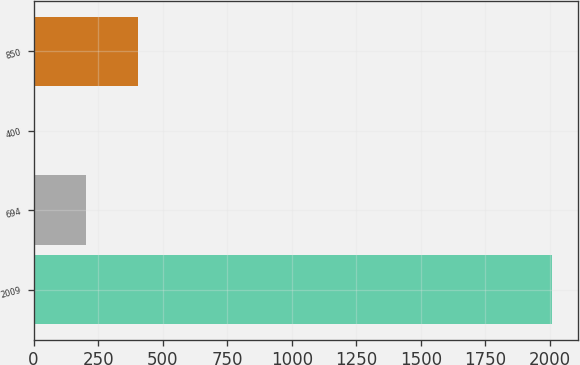<chart> <loc_0><loc_0><loc_500><loc_500><bar_chart><fcel>2009<fcel>694<fcel>400<fcel>850<nl><fcel>2007<fcel>204.75<fcel>4.5<fcel>405<nl></chart> 